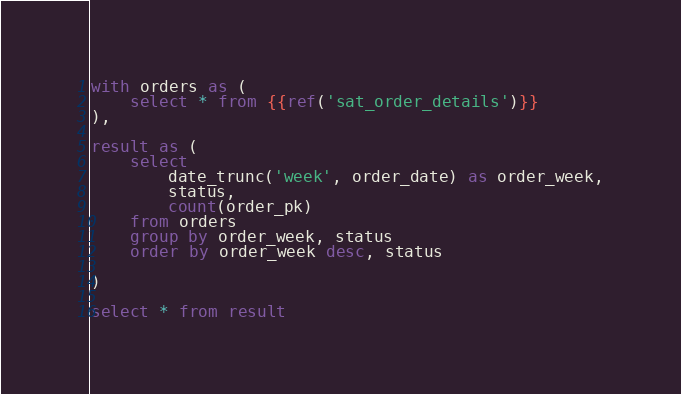Convert code to text. <code><loc_0><loc_0><loc_500><loc_500><_SQL_>with orders as (
    select * from {{ref('sat_order_details')}}
),

result as (
    select
        date_trunc('week', order_date) as order_week,
        status,
        count(order_pk)
    from orders
    group by order_week, status
    order by order_week desc, status

)

select * from result
</code> 